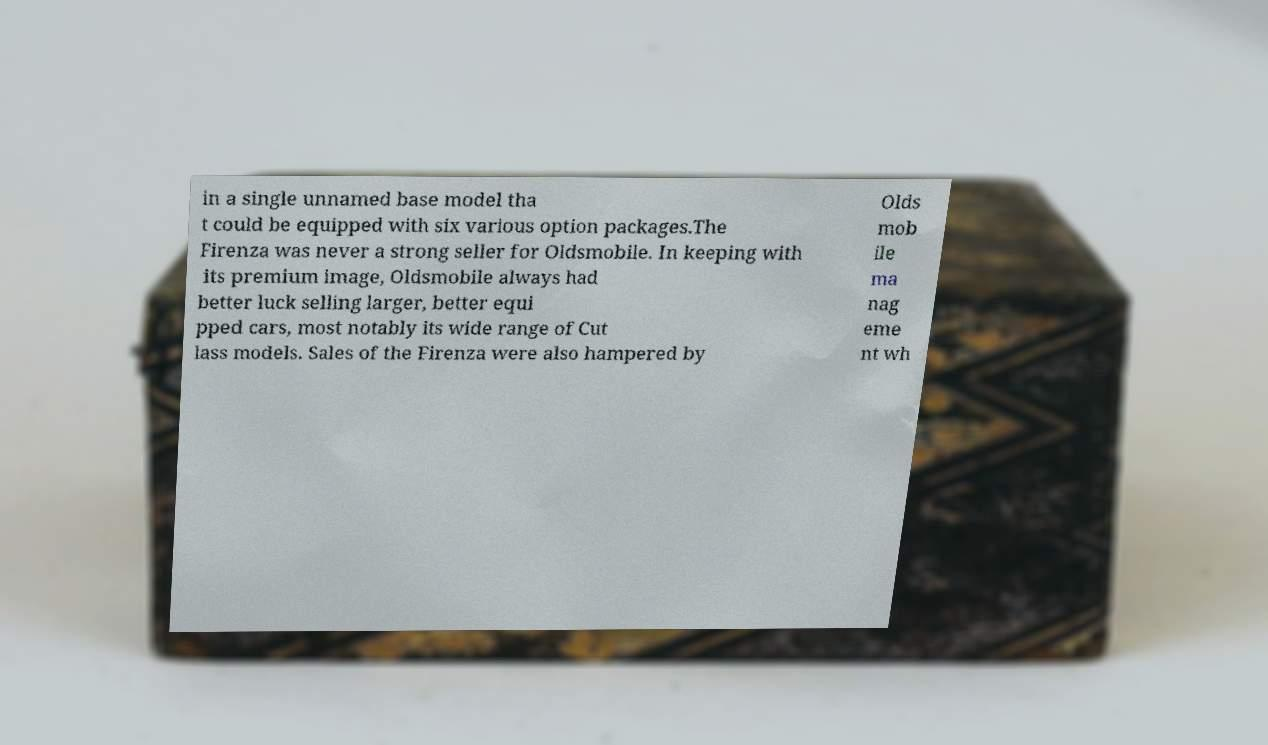Can you accurately transcribe the text from the provided image for me? in a single unnamed base model tha t could be equipped with six various option packages.The Firenza was never a strong seller for Oldsmobile. In keeping with its premium image, Oldsmobile always had better luck selling larger, better equi pped cars, most notably its wide range of Cut lass models. Sales of the Firenza were also hampered by Olds mob ile ma nag eme nt wh 